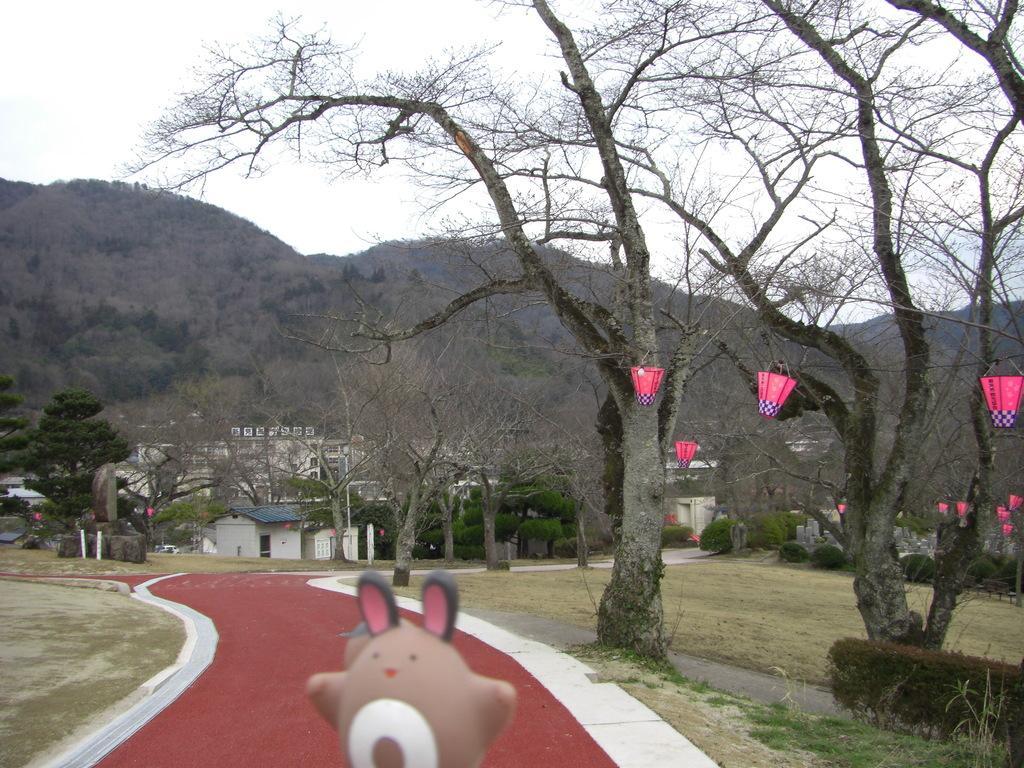Describe this image in one or two sentences. In this picture we can see trees, toy, grass, lights and plants. In the background we can see buildings, house, trees and sky. 